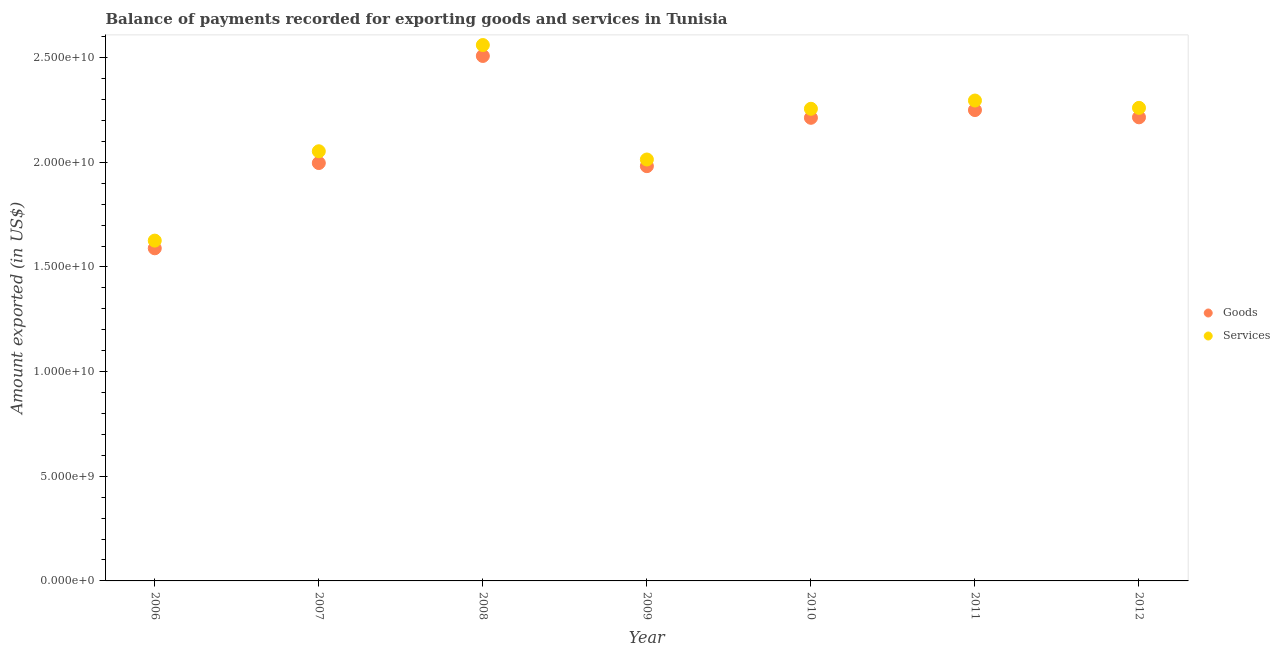Is the number of dotlines equal to the number of legend labels?
Keep it short and to the point. Yes. What is the amount of services exported in 2008?
Your answer should be compact. 2.56e+1. Across all years, what is the maximum amount of services exported?
Make the answer very short. 2.56e+1. Across all years, what is the minimum amount of services exported?
Your answer should be compact. 1.63e+1. In which year was the amount of goods exported maximum?
Ensure brevity in your answer.  2008. In which year was the amount of services exported minimum?
Your answer should be very brief. 2006. What is the total amount of services exported in the graph?
Provide a succinct answer. 1.51e+11. What is the difference between the amount of goods exported in 2009 and that in 2010?
Provide a succinct answer. -2.31e+09. What is the difference between the amount of services exported in 2011 and the amount of goods exported in 2007?
Your answer should be compact. 2.99e+09. What is the average amount of services exported per year?
Keep it short and to the point. 2.15e+1. In the year 2008, what is the difference between the amount of goods exported and amount of services exported?
Offer a terse response. -5.22e+08. What is the ratio of the amount of services exported in 2006 to that in 2008?
Your answer should be very brief. 0.64. Is the amount of goods exported in 2010 less than that in 2011?
Your answer should be compact. Yes. Is the difference between the amount of goods exported in 2006 and 2009 greater than the difference between the amount of services exported in 2006 and 2009?
Give a very brief answer. No. What is the difference between the highest and the second highest amount of goods exported?
Your answer should be very brief. 2.59e+09. What is the difference between the highest and the lowest amount of services exported?
Keep it short and to the point. 9.34e+09. Does the amount of services exported monotonically increase over the years?
Provide a short and direct response. No. Is the amount of goods exported strictly less than the amount of services exported over the years?
Your answer should be very brief. Yes. How many dotlines are there?
Make the answer very short. 2. How many years are there in the graph?
Make the answer very short. 7. Does the graph contain any zero values?
Provide a short and direct response. No. How many legend labels are there?
Your answer should be compact. 2. What is the title of the graph?
Your answer should be very brief. Balance of payments recorded for exporting goods and services in Tunisia. Does "Fixed telephone" appear as one of the legend labels in the graph?
Your answer should be very brief. No. What is the label or title of the Y-axis?
Your answer should be very brief. Amount exported (in US$). What is the Amount exported (in US$) in Goods in 2006?
Your answer should be very brief. 1.59e+1. What is the Amount exported (in US$) of Services in 2006?
Provide a succinct answer. 1.63e+1. What is the Amount exported (in US$) of Goods in 2007?
Ensure brevity in your answer.  2.00e+1. What is the Amount exported (in US$) in Services in 2007?
Your answer should be compact. 2.05e+1. What is the Amount exported (in US$) in Goods in 2008?
Make the answer very short. 2.51e+1. What is the Amount exported (in US$) of Services in 2008?
Your answer should be compact. 2.56e+1. What is the Amount exported (in US$) of Goods in 2009?
Keep it short and to the point. 1.98e+1. What is the Amount exported (in US$) in Services in 2009?
Your response must be concise. 2.01e+1. What is the Amount exported (in US$) of Goods in 2010?
Your answer should be compact. 2.21e+1. What is the Amount exported (in US$) in Services in 2010?
Provide a short and direct response. 2.26e+1. What is the Amount exported (in US$) in Goods in 2011?
Your answer should be compact. 2.25e+1. What is the Amount exported (in US$) in Services in 2011?
Your answer should be compact. 2.30e+1. What is the Amount exported (in US$) of Goods in 2012?
Provide a short and direct response. 2.21e+1. What is the Amount exported (in US$) in Services in 2012?
Provide a short and direct response. 2.26e+1. Across all years, what is the maximum Amount exported (in US$) of Goods?
Provide a succinct answer. 2.51e+1. Across all years, what is the maximum Amount exported (in US$) of Services?
Your response must be concise. 2.56e+1. Across all years, what is the minimum Amount exported (in US$) of Goods?
Provide a succinct answer. 1.59e+1. Across all years, what is the minimum Amount exported (in US$) of Services?
Provide a succinct answer. 1.63e+1. What is the total Amount exported (in US$) in Goods in the graph?
Make the answer very short. 1.48e+11. What is the total Amount exported (in US$) in Services in the graph?
Provide a short and direct response. 1.51e+11. What is the difference between the Amount exported (in US$) in Goods in 2006 and that in 2007?
Offer a terse response. -4.07e+09. What is the difference between the Amount exported (in US$) of Services in 2006 and that in 2007?
Your answer should be compact. -4.27e+09. What is the difference between the Amount exported (in US$) of Goods in 2006 and that in 2008?
Provide a short and direct response. -9.19e+09. What is the difference between the Amount exported (in US$) of Services in 2006 and that in 2008?
Provide a succinct answer. -9.34e+09. What is the difference between the Amount exported (in US$) of Goods in 2006 and that in 2009?
Offer a very short reply. -3.92e+09. What is the difference between the Amount exported (in US$) of Services in 2006 and that in 2009?
Offer a terse response. -3.88e+09. What is the difference between the Amount exported (in US$) in Goods in 2006 and that in 2010?
Make the answer very short. -6.23e+09. What is the difference between the Amount exported (in US$) of Services in 2006 and that in 2010?
Your answer should be very brief. -6.30e+09. What is the difference between the Amount exported (in US$) in Goods in 2006 and that in 2011?
Provide a short and direct response. -6.60e+09. What is the difference between the Amount exported (in US$) in Services in 2006 and that in 2011?
Keep it short and to the point. -6.69e+09. What is the difference between the Amount exported (in US$) of Goods in 2006 and that in 2012?
Offer a terse response. -6.26e+09. What is the difference between the Amount exported (in US$) in Services in 2006 and that in 2012?
Provide a short and direct response. -6.34e+09. What is the difference between the Amount exported (in US$) in Goods in 2007 and that in 2008?
Offer a very short reply. -5.12e+09. What is the difference between the Amount exported (in US$) in Services in 2007 and that in 2008?
Your answer should be very brief. -5.07e+09. What is the difference between the Amount exported (in US$) in Goods in 2007 and that in 2009?
Provide a short and direct response. 1.49e+08. What is the difference between the Amount exported (in US$) in Services in 2007 and that in 2009?
Offer a very short reply. 3.94e+08. What is the difference between the Amount exported (in US$) in Goods in 2007 and that in 2010?
Your answer should be compact. -2.16e+09. What is the difference between the Amount exported (in US$) in Services in 2007 and that in 2010?
Offer a terse response. -2.03e+09. What is the difference between the Amount exported (in US$) in Goods in 2007 and that in 2011?
Keep it short and to the point. -2.53e+09. What is the difference between the Amount exported (in US$) in Services in 2007 and that in 2011?
Offer a terse response. -2.42e+09. What is the difference between the Amount exported (in US$) in Goods in 2007 and that in 2012?
Ensure brevity in your answer.  -2.18e+09. What is the difference between the Amount exported (in US$) in Services in 2007 and that in 2012?
Your answer should be very brief. -2.07e+09. What is the difference between the Amount exported (in US$) of Goods in 2008 and that in 2009?
Offer a very short reply. 5.26e+09. What is the difference between the Amount exported (in US$) in Services in 2008 and that in 2009?
Ensure brevity in your answer.  5.47e+09. What is the difference between the Amount exported (in US$) of Goods in 2008 and that in 2010?
Your answer should be compact. 2.95e+09. What is the difference between the Amount exported (in US$) of Services in 2008 and that in 2010?
Keep it short and to the point. 3.05e+09. What is the difference between the Amount exported (in US$) in Goods in 2008 and that in 2011?
Ensure brevity in your answer.  2.59e+09. What is the difference between the Amount exported (in US$) in Services in 2008 and that in 2011?
Ensure brevity in your answer.  2.65e+09. What is the difference between the Amount exported (in US$) in Goods in 2008 and that in 2012?
Your response must be concise. 2.93e+09. What is the difference between the Amount exported (in US$) of Services in 2008 and that in 2012?
Offer a terse response. 3.00e+09. What is the difference between the Amount exported (in US$) of Goods in 2009 and that in 2010?
Make the answer very short. -2.31e+09. What is the difference between the Amount exported (in US$) in Services in 2009 and that in 2010?
Make the answer very short. -2.42e+09. What is the difference between the Amount exported (in US$) in Goods in 2009 and that in 2011?
Give a very brief answer. -2.68e+09. What is the difference between the Amount exported (in US$) of Services in 2009 and that in 2011?
Make the answer very short. -2.82e+09. What is the difference between the Amount exported (in US$) of Goods in 2009 and that in 2012?
Provide a succinct answer. -2.33e+09. What is the difference between the Amount exported (in US$) in Services in 2009 and that in 2012?
Give a very brief answer. -2.47e+09. What is the difference between the Amount exported (in US$) of Goods in 2010 and that in 2011?
Offer a very short reply. -3.69e+08. What is the difference between the Amount exported (in US$) in Services in 2010 and that in 2011?
Keep it short and to the point. -3.94e+08. What is the difference between the Amount exported (in US$) of Goods in 2010 and that in 2012?
Your answer should be compact. -2.28e+07. What is the difference between the Amount exported (in US$) of Services in 2010 and that in 2012?
Offer a very short reply. -4.48e+07. What is the difference between the Amount exported (in US$) in Goods in 2011 and that in 2012?
Make the answer very short. 3.47e+08. What is the difference between the Amount exported (in US$) in Services in 2011 and that in 2012?
Provide a succinct answer. 3.50e+08. What is the difference between the Amount exported (in US$) in Goods in 2006 and the Amount exported (in US$) in Services in 2007?
Provide a succinct answer. -4.64e+09. What is the difference between the Amount exported (in US$) in Goods in 2006 and the Amount exported (in US$) in Services in 2008?
Offer a very short reply. -9.71e+09. What is the difference between the Amount exported (in US$) in Goods in 2006 and the Amount exported (in US$) in Services in 2009?
Keep it short and to the point. -4.24e+09. What is the difference between the Amount exported (in US$) in Goods in 2006 and the Amount exported (in US$) in Services in 2010?
Provide a short and direct response. -6.66e+09. What is the difference between the Amount exported (in US$) of Goods in 2006 and the Amount exported (in US$) of Services in 2011?
Offer a terse response. -7.06e+09. What is the difference between the Amount exported (in US$) of Goods in 2006 and the Amount exported (in US$) of Services in 2012?
Your answer should be very brief. -6.71e+09. What is the difference between the Amount exported (in US$) of Goods in 2007 and the Amount exported (in US$) of Services in 2008?
Your response must be concise. -5.64e+09. What is the difference between the Amount exported (in US$) in Goods in 2007 and the Amount exported (in US$) in Services in 2009?
Make the answer very short. -1.69e+08. What is the difference between the Amount exported (in US$) in Goods in 2007 and the Amount exported (in US$) in Services in 2010?
Your answer should be very brief. -2.59e+09. What is the difference between the Amount exported (in US$) of Goods in 2007 and the Amount exported (in US$) of Services in 2011?
Give a very brief answer. -2.99e+09. What is the difference between the Amount exported (in US$) in Goods in 2007 and the Amount exported (in US$) in Services in 2012?
Offer a very short reply. -2.64e+09. What is the difference between the Amount exported (in US$) in Goods in 2008 and the Amount exported (in US$) in Services in 2009?
Provide a succinct answer. 4.95e+09. What is the difference between the Amount exported (in US$) in Goods in 2008 and the Amount exported (in US$) in Services in 2010?
Offer a terse response. 2.52e+09. What is the difference between the Amount exported (in US$) of Goods in 2008 and the Amount exported (in US$) of Services in 2011?
Your answer should be very brief. 2.13e+09. What is the difference between the Amount exported (in US$) in Goods in 2008 and the Amount exported (in US$) in Services in 2012?
Keep it short and to the point. 2.48e+09. What is the difference between the Amount exported (in US$) of Goods in 2009 and the Amount exported (in US$) of Services in 2010?
Give a very brief answer. -2.74e+09. What is the difference between the Amount exported (in US$) of Goods in 2009 and the Amount exported (in US$) of Services in 2011?
Provide a succinct answer. -3.13e+09. What is the difference between the Amount exported (in US$) in Goods in 2009 and the Amount exported (in US$) in Services in 2012?
Your answer should be very brief. -2.79e+09. What is the difference between the Amount exported (in US$) of Goods in 2010 and the Amount exported (in US$) of Services in 2011?
Provide a short and direct response. -8.25e+08. What is the difference between the Amount exported (in US$) in Goods in 2010 and the Amount exported (in US$) in Services in 2012?
Your response must be concise. -4.75e+08. What is the difference between the Amount exported (in US$) of Goods in 2011 and the Amount exported (in US$) of Services in 2012?
Provide a short and direct response. -1.06e+08. What is the average Amount exported (in US$) in Goods per year?
Make the answer very short. 2.11e+1. What is the average Amount exported (in US$) of Services per year?
Offer a terse response. 2.15e+1. In the year 2006, what is the difference between the Amount exported (in US$) of Goods and Amount exported (in US$) of Services?
Your answer should be compact. -3.67e+08. In the year 2007, what is the difference between the Amount exported (in US$) in Goods and Amount exported (in US$) in Services?
Your answer should be very brief. -5.63e+08. In the year 2008, what is the difference between the Amount exported (in US$) in Goods and Amount exported (in US$) in Services?
Your answer should be compact. -5.22e+08. In the year 2009, what is the difference between the Amount exported (in US$) in Goods and Amount exported (in US$) in Services?
Offer a terse response. -3.18e+08. In the year 2010, what is the difference between the Amount exported (in US$) in Goods and Amount exported (in US$) in Services?
Your answer should be compact. -4.30e+08. In the year 2011, what is the difference between the Amount exported (in US$) in Goods and Amount exported (in US$) in Services?
Ensure brevity in your answer.  -4.55e+08. In the year 2012, what is the difference between the Amount exported (in US$) in Goods and Amount exported (in US$) in Services?
Offer a very short reply. -4.52e+08. What is the ratio of the Amount exported (in US$) of Goods in 2006 to that in 2007?
Ensure brevity in your answer.  0.8. What is the ratio of the Amount exported (in US$) in Services in 2006 to that in 2007?
Your answer should be very brief. 0.79. What is the ratio of the Amount exported (in US$) of Goods in 2006 to that in 2008?
Your answer should be very brief. 0.63. What is the ratio of the Amount exported (in US$) of Services in 2006 to that in 2008?
Provide a succinct answer. 0.64. What is the ratio of the Amount exported (in US$) of Goods in 2006 to that in 2009?
Give a very brief answer. 0.8. What is the ratio of the Amount exported (in US$) in Services in 2006 to that in 2009?
Ensure brevity in your answer.  0.81. What is the ratio of the Amount exported (in US$) in Goods in 2006 to that in 2010?
Your answer should be compact. 0.72. What is the ratio of the Amount exported (in US$) in Services in 2006 to that in 2010?
Give a very brief answer. 0.72. What is the ratio of the Amount exported (in US$) of Goods in 2006 to that in 2011?
Offer a very short reply. 0.71. What is the ratio of the Amount exported (in US$) in Services in 2006 to that in 2011?
Ensure brevity in your answer.  0.71. What is the ratio of the Amount exported (in US$) of Goods in 2006 to that in 2012?
Ensure brevity in your answer.  0.72. What is the ratio of the Amount exported (in US$) in Services in 2006 to that in 2012?
Ensure brevity in your answer.  0.72. What is the ratio of the Amount exported (in US$) of Goods in 2007 to that in 2008?
Keep it short and to the point. 0.8. What is the ratio of the Amount exported (in US$) of Services in 2007 to that in 2008?
Provide a succinct answer. 0.8. What is the ratio of the Amount exported (in US$) in Goods in 2007 to that in 2009?
Give a very brief answer. 1.01. What is the ratio of the Amount exported (in US$) of Services in 2007 to that in 2009?
Give a very brief answer. 1.02. What is the ratio of the Amount exported (in US$) of Goods in 2007 to that in 2010?
Offer a very short reply. 0.9. What is the ratio of the Amount exported (in US$) in Services in 2007 to that in 2010?
Your answer should be very brief. 0.91. What is the ratio of the Amount exported (in US$) of Goods in 2007 to that in 2011?
Make the answer very short. 0.89. What is the ratio of the Amount exported (in US$) of Services in 2007 to that in 2011?
Give a very brief answer. 0.89. What is the ratio of the Amount exported (in US$) in Goods in 2007 to that in 2012?
Your answer should be compact. 0.9. What is the ratio of the Amount exported (in US$) in Services in 2007 to that in 2012?
Provide a short and direct response. 0.91. What is the ratio of the Amount exported (in US$) in Goods in 2008 to that in 2009?
Give a very brief answer. 1.27. What is the ratio of the Amount exported (in US$) of Services in 2008 to that in 2009?
Offer a very short reply. 1.27. What is the ratio of the Amount exported (in US$) of Goods in 2008 to that in 2010?
Provide a succinct answer. 1.13. What is the ratio of the Amount exported (in US$) of Services in 2008 to that in 2010?
Provide a short and direct response. 1.14. What is the ratio of the Amount exported (in US$) in Goods in 2008 to that in 2011?
Your answer should be compact. 1.11. What is the ratio of the Amount exported (in US$) in Services in 2008 to that in 2011?
Make the answer very short. 1.12. What is the ratio of the Amount exported (in US$) in Goods in 2008 to that in 2012?
Give a very brief answer. 1.13. What is the ratio of the Amount exported (in US$) in Services in 2008 to that in 2012?
Make the answer very short. 1.13. What is the ratio of the Amount exported (in US$) in Goods in 2009 to that in 2010?
Your answer should be compact. 0.9. What is the ratio of the Amount exported (in US$) of Services in 2009 to that in 2010?
Keep it short and to the point. 0.89. What is the ratio of the Amount exported (in US$) of Goods in 2009 to that in 2011?
Your response must be concise. 0.88. What is the ratio of the Amount exported (in US$) in Services in 2009 to that in 2011?
Provide a short and direct response. 0.88. What is the ratio of the Amount exported (in US$) of Goods in 2009 to that in 2012?
Your response must be concise. 0.89. What is the ratio of the Amount exported (in US$) in Services in 2009 to that in 2012?
Offer a very short reply. 0.89. What is the ratio of the Amount exported (in US$) in Goods in 2010 to that in 2011?
Provide a short and direct response. 0.98. What is the ratio of the Amount exported (in US$) in Services in 2010 to that in 2011?
Provide a short and direct response. 0.98. What is the ratio of the Amount exported (in US$) of Goods in 2010 to that in 2012?
Provide a succinct answer. 1. What is the ratio of the Amount exported (in US$) of Services in 2010 to that in 2012?
Offer a terse response. 1. What is the ratio of the Amount exported (in US$) in Goods in 2011 to that in 2012?
Provide a short and direct response. 1.02. What is the ratio of the Amount exported (in US$) of Services in 2011 to that in 2012?
Keep it short and to the point. 1.02. What is the difference between the highest and the second highest Amount exported (in US$) in Goods?
Make the answer very short. 2.59e+09. What is the difference between the highest and the second highest Amount exported (in US$) in Services?
Your answer should be very brief. 2.65e+09. What is the difference between the highest and the lowest Amount exported (in US$) of Goods?
Your answer should be very brief. 9.19e+09. What is the difference between the highest and the lowest Amount exported (in US$) in Services?
Keep it short and to the point. 9.34e+09. 